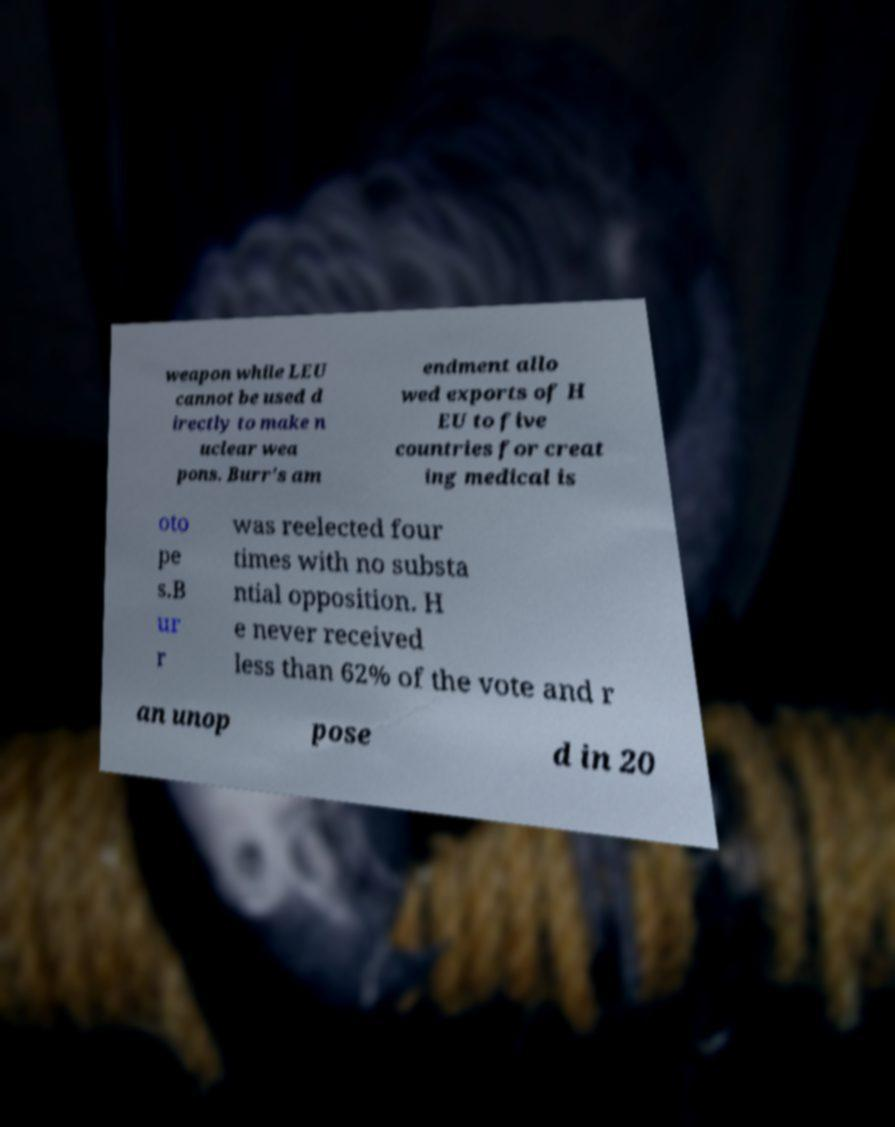What messages or text are displayed in this image? I need them in a readable, typed format. weapon while LEU cannot be used d irectly to make n uclear wea pons. Burr's am endment allo wed exports of H EU to five countries for creat ing medical is oto pe s.B ur r was reelected four times with no substa ntial opposition. H e never received less than 62% of the vote and r an unop pose d in 20 